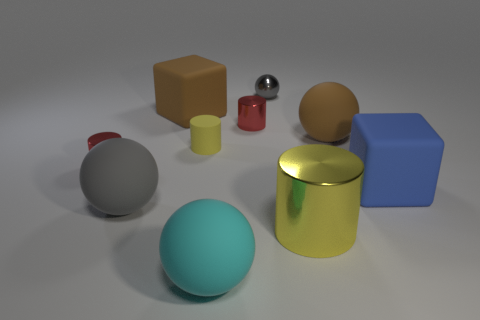Subtract all brown matte balls. How many balls are left? 3 Subtract all brown balls. How many balls are left? 3 Subtract all cyan spheres. How many red cylinders are left? 2 Subtract 1 brown balls. How many objects are left? 9 Subtract all blocks. How many objects are left? 8 Subtract 2 spheres. How many spheres are left? 2 Subtract all cyan cubes. Subtract all gray balls. How many cubes are left? 2 Subtract all gray cylinders. Subtract all red cylinders. How many objects are left? 8 Add 4 gray matte spheres. How many gray matte spheres are left? 5 Add 5 big yellow cylinders. How many big yellow cylinders exist? 6 